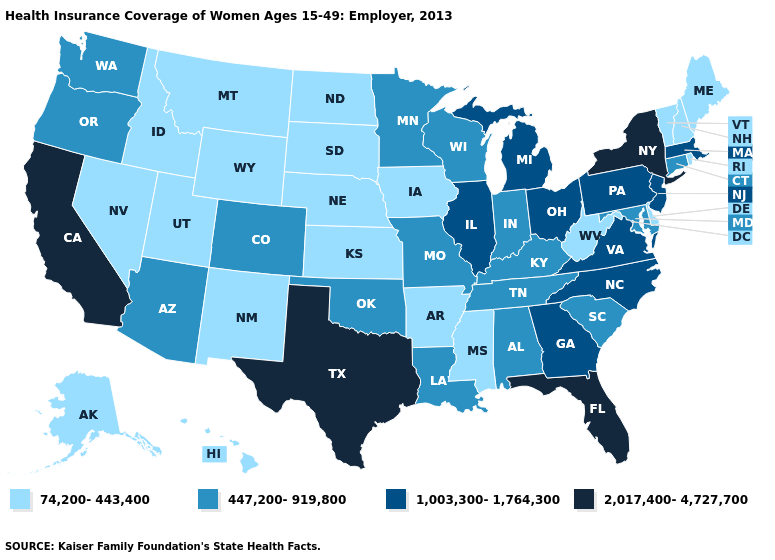What is the highest value in states that border Michigan?
Short answer required. 1,003,300-1,764,300. Does the first symbol in the legend represent the smallest category?
Keep it brief. Yes. Is the legend a continuous bar?
Write a very short answer. No. Which states have the lowest value in the Northeast?
Answer briefly. Maine, New Hampshire, Rhode Island, Vermont. How many symbols are there in the legend?
Quick response, please. 4. What is the value of California?
Be succinct. 2,017,400-4,727,700. What is the value of Kentucky?
Be succinct. 447,200-919,800. What is the highest value in states that border Oklahoma?
Write a very short answer. 2,017,400-4,727,700. Does Connecticut have the lowest value in the USA?
Give a very brief answer. No. Does Oklahoma have the highest value in the USA?
Short answer required. No. Among the states that border Mississippi , which have the lowest value?
Quick response, please. Arkansas. Which states have the lowest value in the USA?
Write a very short answer. Alaska, Arkansas, Delaware, Hawaii, Idaho, Iowa, Kansas, Maine, Mississippi, Montana, Nebraska, Nevada, New Hampshire, New Mexico, North Dakota, Rhode Island, South Dakota, Utah, Vermont, West Virginia, Wyoming. Name the states that have a value in the range 447,200-919,800?
Concise answer only. Alabama, Arizona, Colorado, Connecticut, Indiana, Kentucky, Louisiana, Maryland, Minnesota, Missouri, Oklahoma, Oregon, South Carolina, Tennessee, Washington, Wisconsin. Name the states that have a value in the range 447,200-919,800?
Be succinct. Alabama, Arizona, Colorado, Connecticut, Indiana, Kentucky, Louisiana, Maryland, Minnesota, Missouri, Oklahoma, Oregon, South Carolina, Tennessee, Washington, Wisconsin. What is the value of Vermont?
Write a very short answer. 74,200-443,400. 